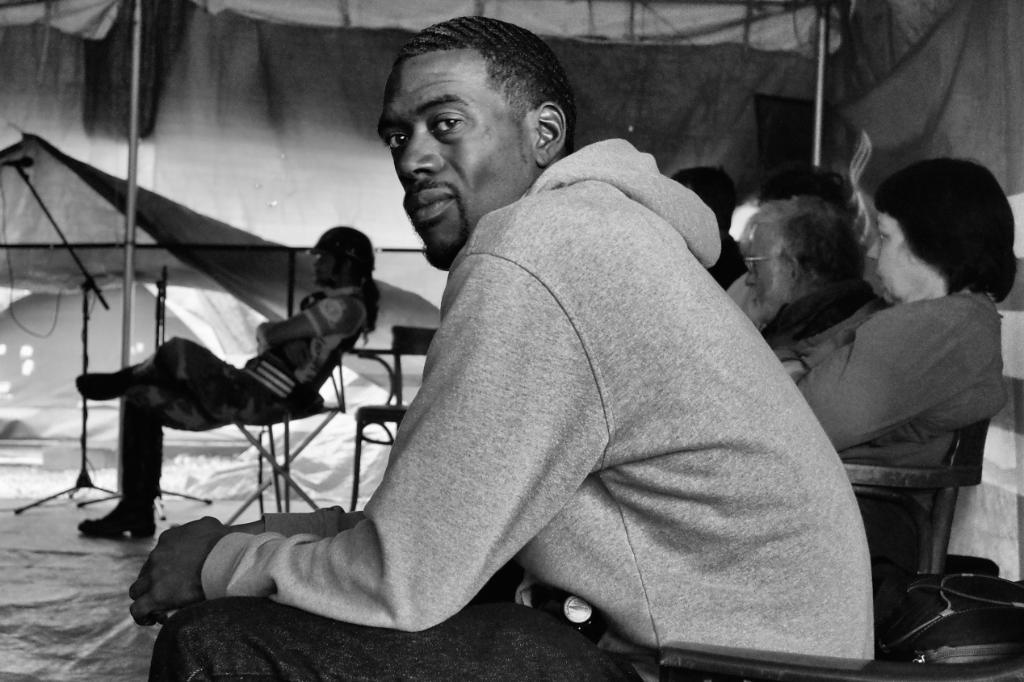What is the color scheme of the image? The image is black and white. What are the people in the image doing? The people are sitting on chairs in the image. What can be seen in the top left and top right of the image? There are poles in both the top left and top right of the image. What is located on the left side of the image? There is a mic on the left side of the image. What type of joke is being told by the person standing next to the flag in the image? There is no person standing next to a flag in the image, and therefore no joke is being told. Does the existence of the mic in the image prove the existence of an audio recording device? The presence of a mic in the image suggests that there might be an audio recording device, but it does not definitively prove its existence. 